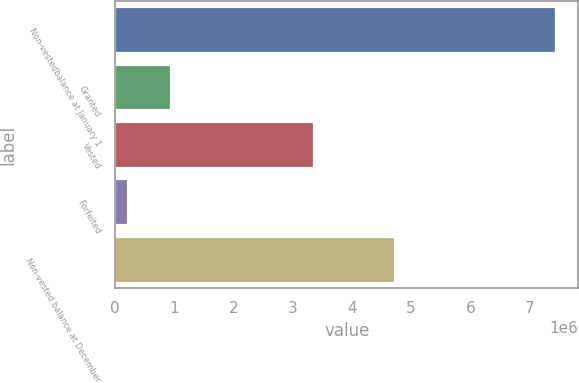Convert chart. <chart><loc_0><loc_0><loc_500><loc_500><bar_chart><fcel>Non-vestedbalance at January 1<fcel>Granted<fcel>Vested<fcel>Forfeited<fcel>Non-vested balance at December<nl><fcel>7.4518e+06<fcel>943685<fcel>3.36044e+06<fcel>220561<fcel>4.7288e+06<nl></chart> 